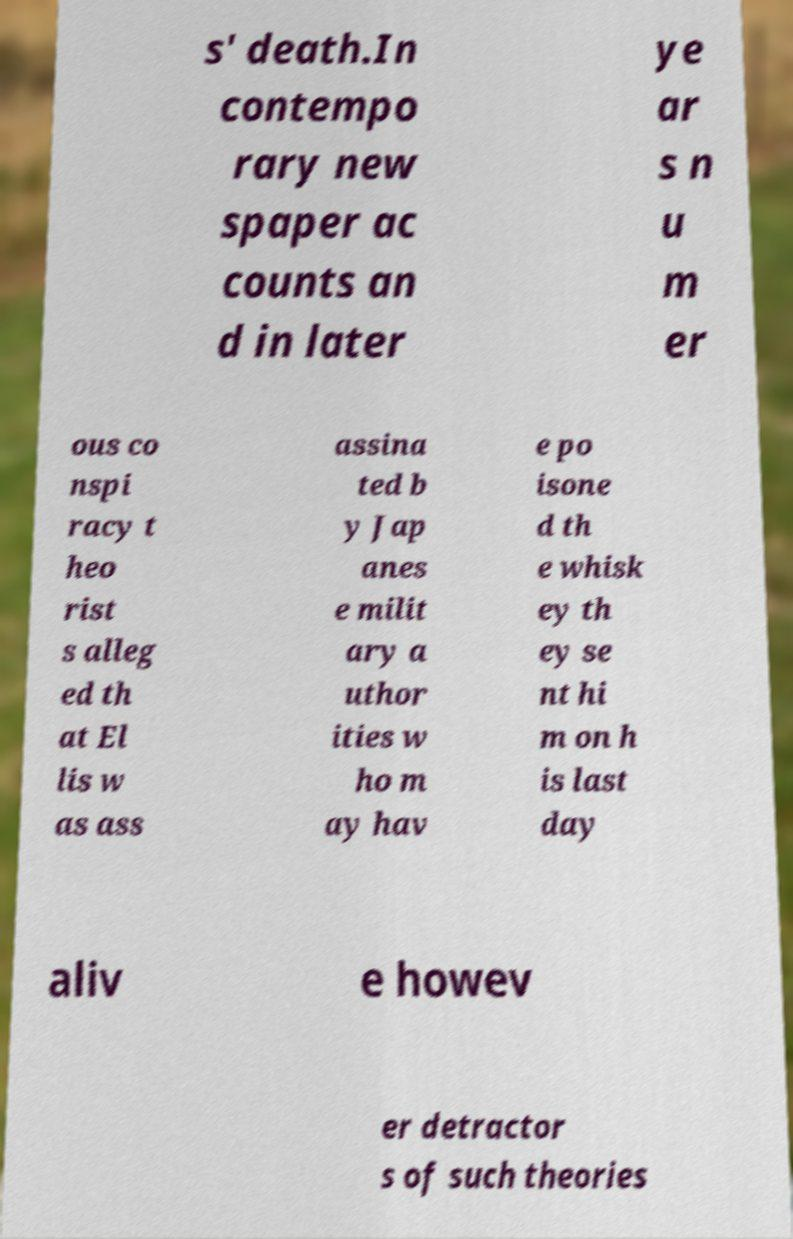Could you extract and type out the text from this image? s' death.In contempo rary new spaper ac counts an d in later ye ar s n u m er ous co nspi racy t heo rist s alleg ed th at El lis w as ass assina ted b y Jap anes e milit ary a uthor ities w ho m ay hav e po isone d th e whisk ey th ey se nt hi m on h is last day aliv e howev er detractor s of such theories 